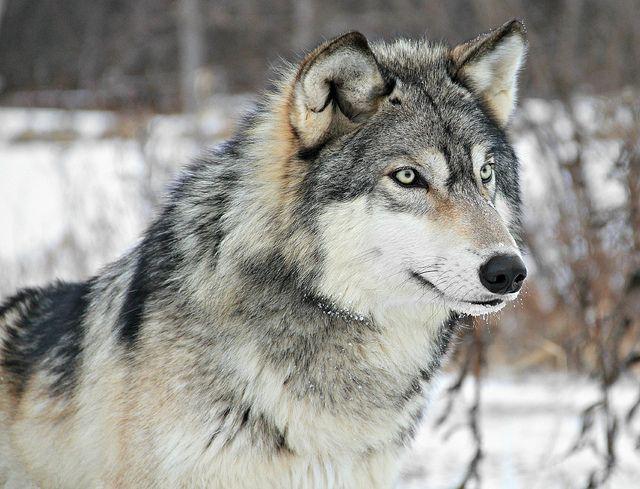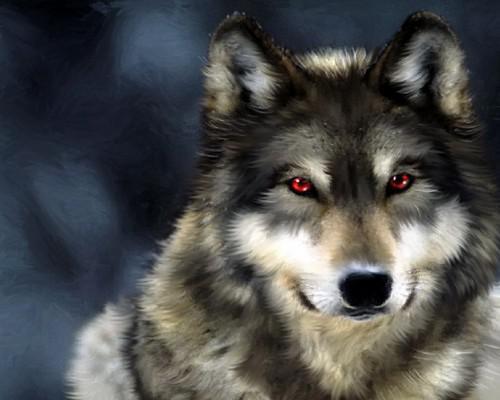The first image is the image on the left, the second image is the image on the right. Examine the images to the left and right. Is the description "There are at least three wolves." accurate? Answer yes or no. No. The first image is the image on the left, the second image is the image on the right. For the images displayed, is the sentence "The image on the left contains one more wolf than the image on the right." factually correct? Answer yes or no. No. 